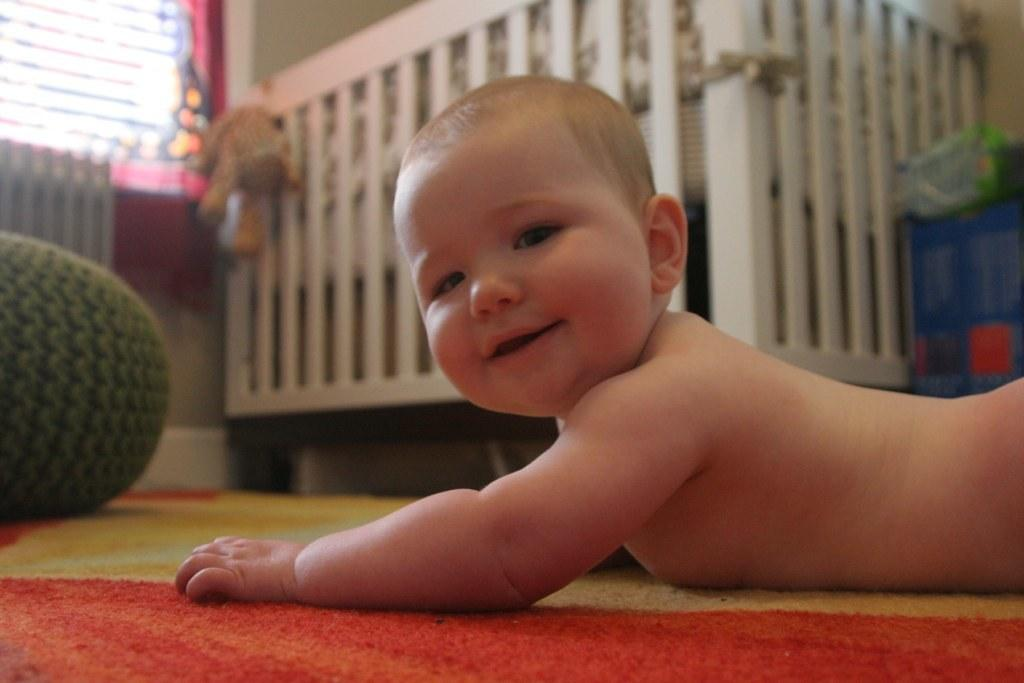What is the main subject of the image? The main subject of the image is a baby lying on the floor. Can you describe the baby's surroundings? In the background of the image, there is a baby crib. What type of animal can be seen at the zoo in the image? There is no zoo or animal present in the image; it features a baby lying on the floor and a baby crib in the background. 